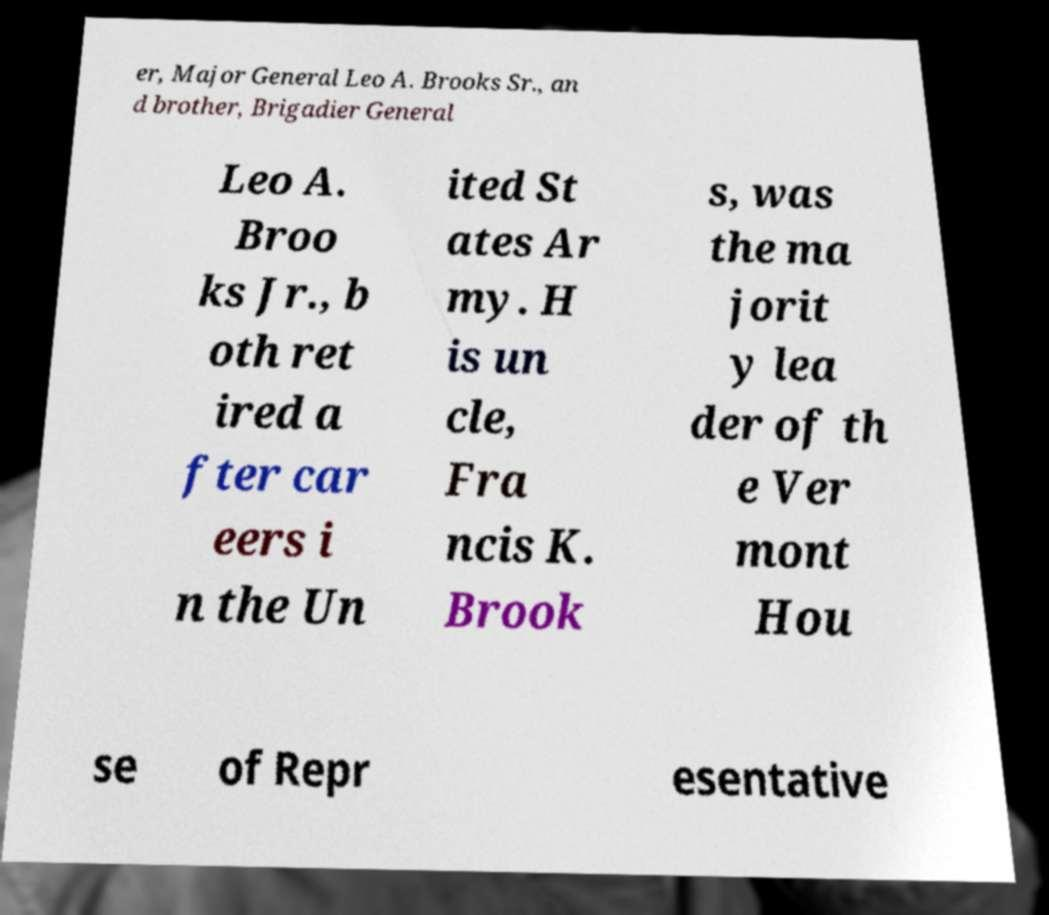Can you read and provide the text displayed in the image?This photo seems to have some interesting text. Can you extract and type it out for me? er, Major General Leo A. Brooks Sr., an d brother, Brigadier General Leo A. Broo ks Jr., b oth ret ired a fter car eers i n the Un ited St ates Ar my. H is un cle, Fra ncis K. Brook s, was the ma jorit y lea der of th e Ver mont Hou se of Repr esentative 